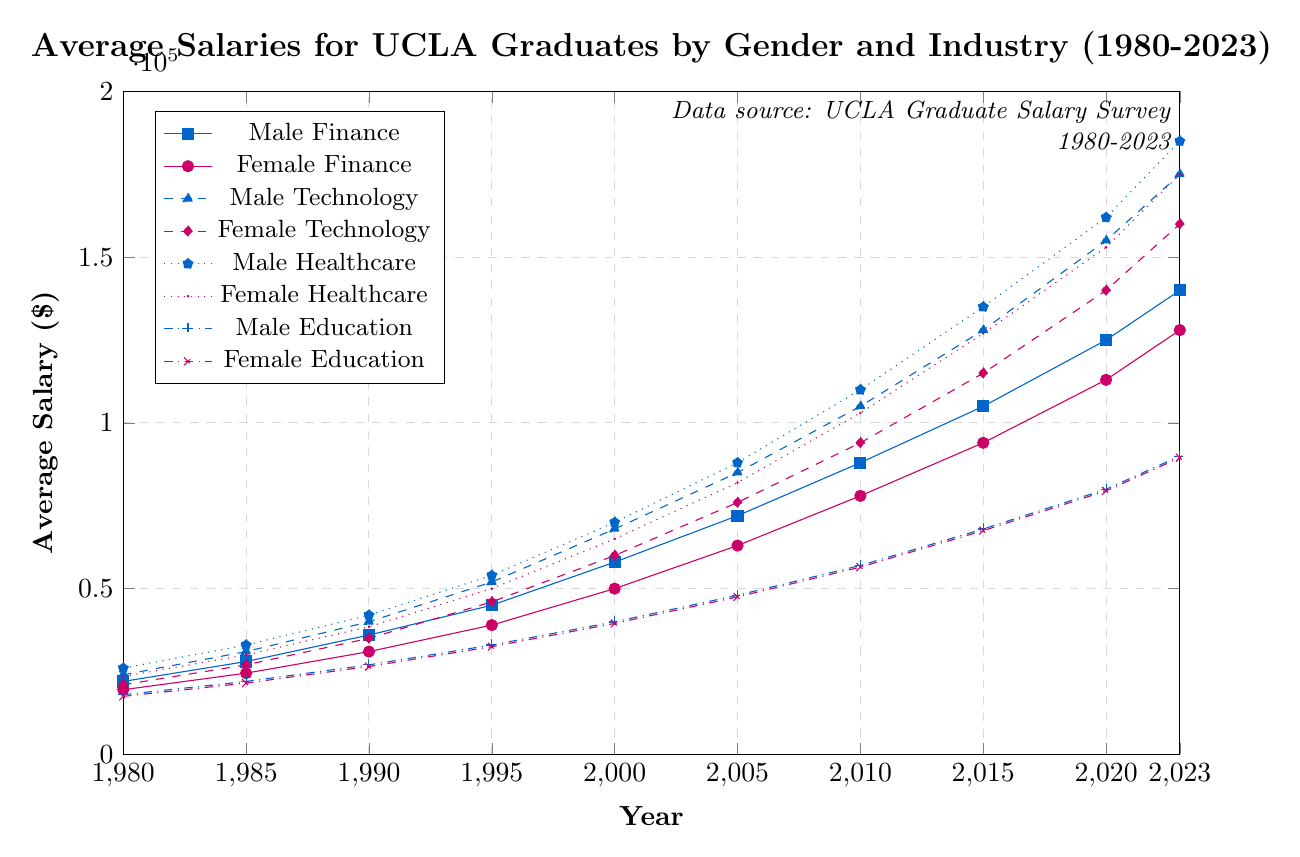What are the average salaries of male and female graduates in the Finance industry in 2023? The average salaries in the Finance industry for male and female graduates in 2023 are given directly in the figure. They can be visually referenced.
Answer: $140,000 and $128,000 Which industry shows the highest average salary for female graduates in 2023? By comparing the highest points on the respective lines for female graduates in different industries in 2023, Healthcare shows the highest at $175,000.
Answer: Healthcare What is the difference in average salary between male and female graduates in Technology in the year 2000? The salaries for male and female graduates in the Technology industry in 2000 can be referenced, then the difference is calculated: $68,000 - $60,000.
Answer: $8,000 In which year did the average salary for male graduates in Healthcare first surpass $100,000? Review the Healthcare male line and identify the first year it crosses $100,000. This occurs in 2005 where it's $110,000.
Answer: 2005 What is the trend in average salary for female graduates in Education from 1980 to 2023? By following the progression of the Education female line from 1980 to 2023, there's a consistent increase in salary over the years.
Answer: Increasing trend How much did the average salary for male graduates in Finance increase from 1980 to 2023? Subtract the 1980 salary from the 2023 salary for male Finance graduates: $140,000 - $22,000.
Answer: $118,000 By how much did the average salary for male and female graduates in Healthcare differ in 1995? The average salary for male graduates in Healthcare in 1995 is $54,000, and for female graduates it's $50,000. The difference is calculated: $54,000 - $50,000.
Answer: $4,000 Which gender had a higher average salary in the Education industry in 2010, and by how much? Compare the 2010 salaries for males ($57,000) and females ($56,500) in Education, then find the difference: $57,000 - $56,500.
Answer: Male, by $500 Which industry had the smallest gender pay gap in 2023? By reviewing the salary differences for all industries in 2023, Education shows the smallest gap: $90,000 (male) - $89,500 (female).
Answer: Education What is the average salary difference between male graduates in Technology and Healthcare in 2020? Find the salaries for male graduates in Technology ($155,000) and Healthcare ($162,000) in 2020, then compute the difference: $162,000 - $155,000.
Answer: $7,000 